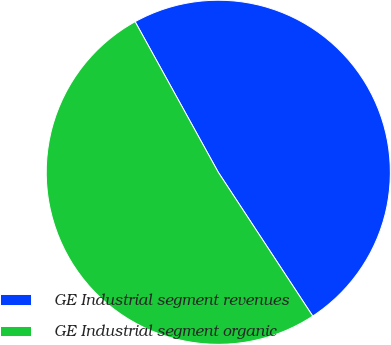<chart> <loc_0><loc_0><loc_500><loc_500><pie_chart><fcel>GE Industrial segment revenues<fcel>GE Industrial segment organic<nl><fcel>48.78%<fcel>51.22%<nl></chart> 